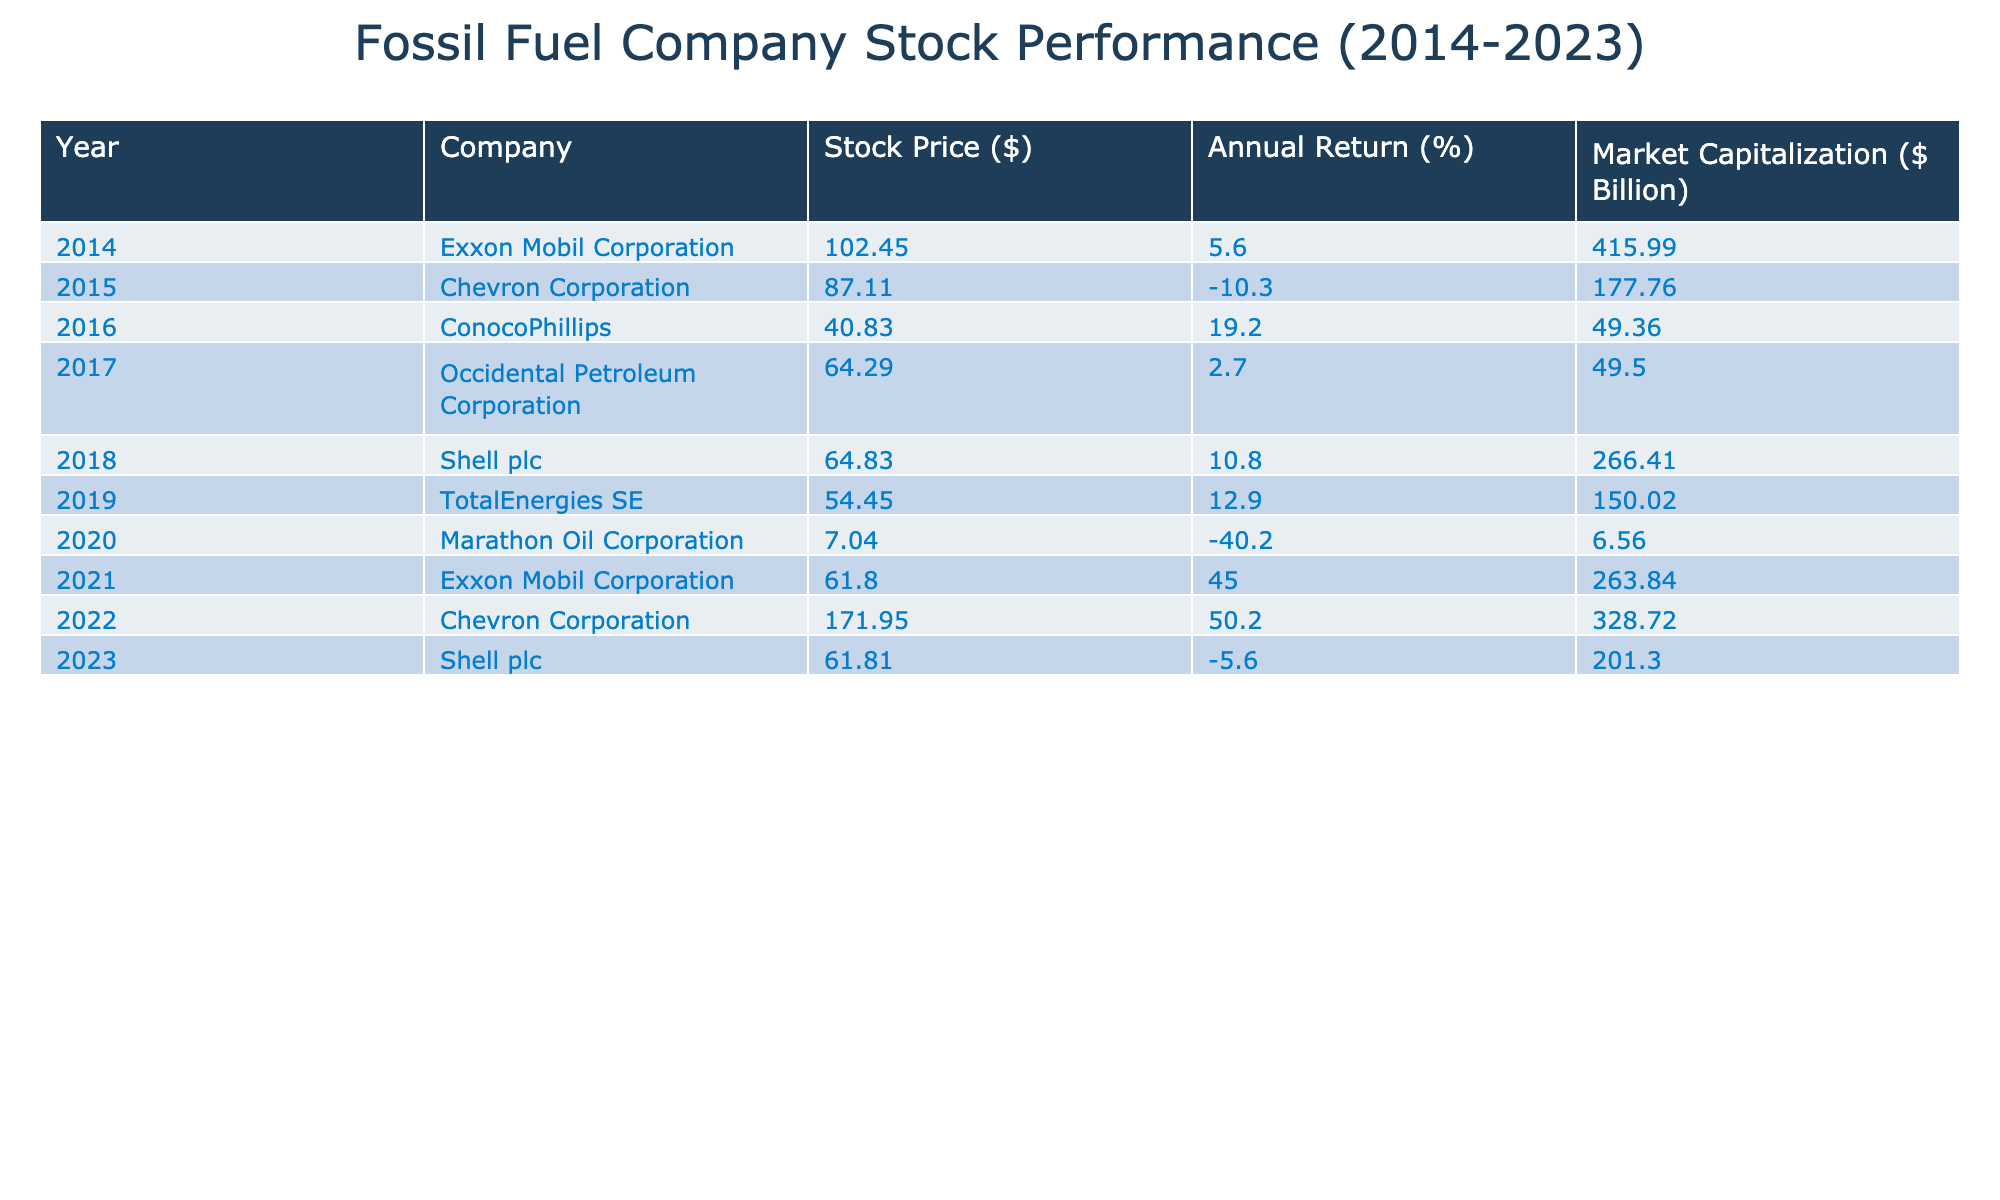What was the stock price of Chevron Corporation in 2022? The table indicates that in 2022, the stock price of Chevron Corporation was 171.95 dollars. This can be found directly under the "Stock Price ($)" column for the row corresponding to the year 2022 and the company Chevron Corporation.
Answer: 171.95 Which company had the highest annual return in 2021? From the table, the annual return values are present for each company in 2021. The data shows that Exxon Mobil Corporation had an annual return of 45.0%, which is the highest among the listed companies for that year.
Answer: Exxon Mobil Corporation What is the market capitalization of TotalEnergies SE in 2019? Referring to the table, TotalEnergies SE's market capitalization in 2019 is 150.02 billion dollars. This figure can be found in the "Market Capitalization ($ Billion)" column corresponding to the year 2019.
Answer: 150.02 Over the entire decade, which company had the most fluctuation in stock price? To determine the company with the most fluctuation, we can look at the stock prices across the years for each company. For example, Exxon Mobil's price moved from 102.45 in 2014 to 61.80 in 2021, experiencing a notable drop and then rising again. Conversely, Marathon Oil's price plunged drastically to 7.04 in 2020 but reflects a lower overall range. Calculating the range (maximum - minimum) of each company will reveal significant fluctuations. After calculations, it is found that Exxon Mobil Corporation has the highest fluctuation, with a range of 40.65 between the highest price in 2014 and the lowest price in 2021.
Answer: Exxon Mobil Corporation Was there any year when no company posted a negative annual return? By inspecting the "Annual Return (%)" section for each year, it is clear that certain years saw negative returns for some companies. However, each year shows at least one company with a negative return. Thus, reviewing the entire decade confirms that there was no single year where all companies had positive returns.
Answer: No 